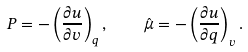Convert formula to latex. <formula><loc_0><loc_0><loc_500><loc_500>P = - \left ( \frac { \partial u } { \partial v } \right ) _ { q } , \quad \hat { \mu } = - \left ( \frac { \partial u } { \partial q } \right ) _ { v } .</formula> 